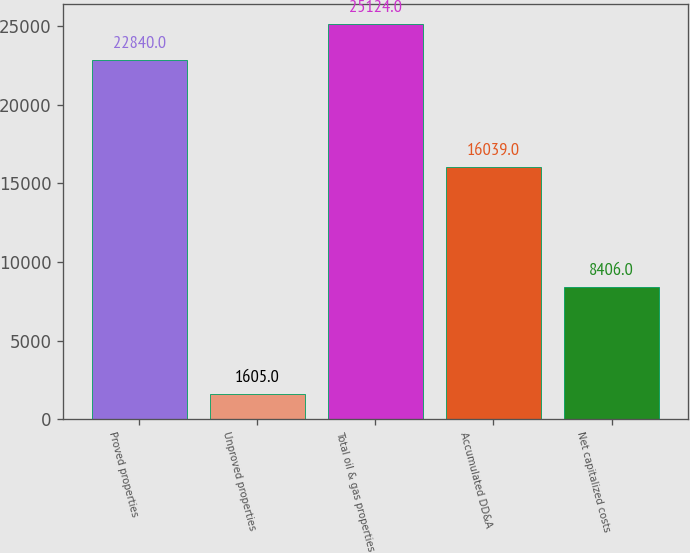Convert chart. <chart><loc_0><loc_0><loc_500><loc_500><bar_chart><fcel>Proved properties<fcel>Unproved properties<fcel>Total oil & gas properties<fcel>Accumulated DD&A<fcel>Net capitalized costs<nl><fcel>22840<fcel>1605<fcel>25124<fcel>16039<fcel>8406<nl></chart> 